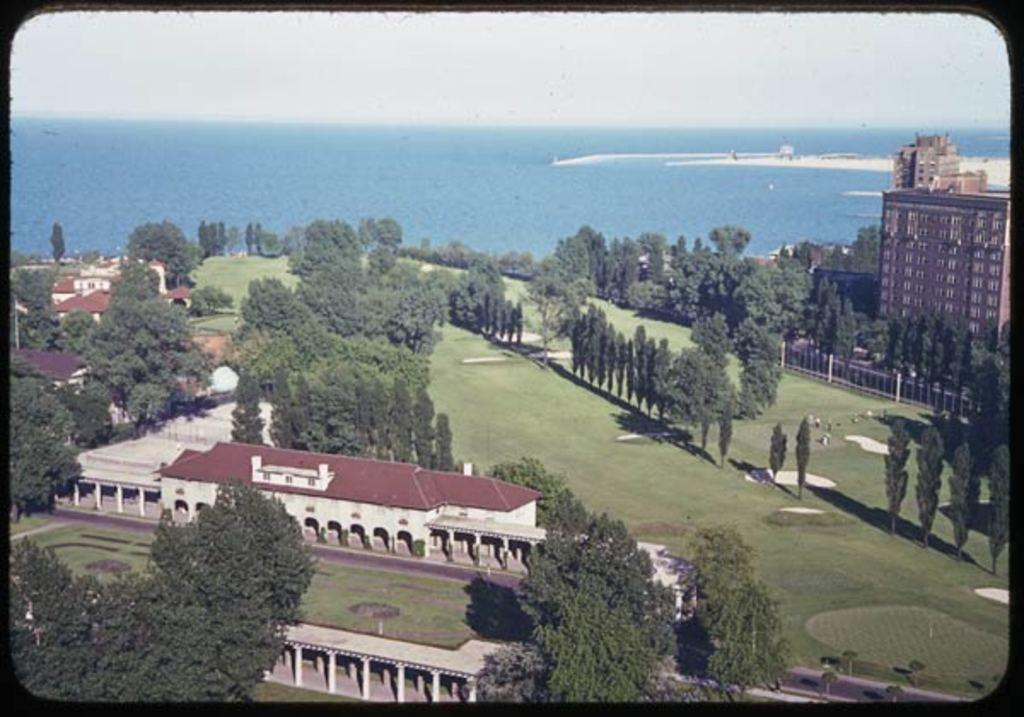Please provide a concise description of this image. In this picture we can see buildings, trees, grass and water. 